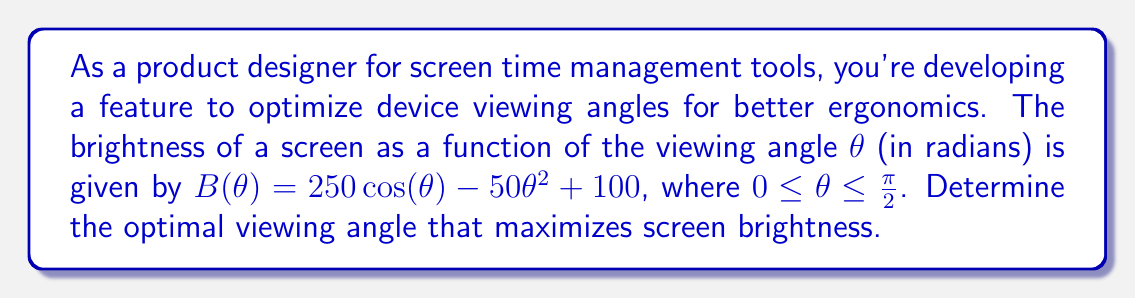What is the answer to this math problem? To find the optimal viewing angle that maximizes screen brightness, we need to find the maximum of the function $B(\theta)$. We can do this by finding where the derivative of $B(\theta)$ equals zero.

1. First, let's find the derivative of $B(\theta)$:
   $$B'(\theta) = -250 \sin(\theta) - 100\theta$$

2. Set the derivative equal to zero and solve for θ:
   $$B'(\theta) = 0$$
   $$-250 \sin(\theta) - 100\theta = 0$$

3. This equation cannot be solved algebraically, so we need to use numerical methods. We can use Newton's method or a graphing calculator to find the solution.

4. Using a numerical solver, we find that the equation is satisfied when:
   $$\theta \approx 0.3935 \text{ radians}$$

5. To confirm this is a maximum (not a minimum), we can check the second derivative:
   $$B''(\theta) = -250 \cos(\theta) - 100$$
   At $\theta \approx 0.3935$, $B''(\theta) < 0$, confirming it's a maximum.

6. Convert the result to degrees:
   $$0.3935 \text{ radians} \times \frac{180°}{\pi} \approx 22.55°$$

Therefore, the optimal viewing angle that maximizes screen brightness is approximately 22.55°.
Answer: 22.55° 